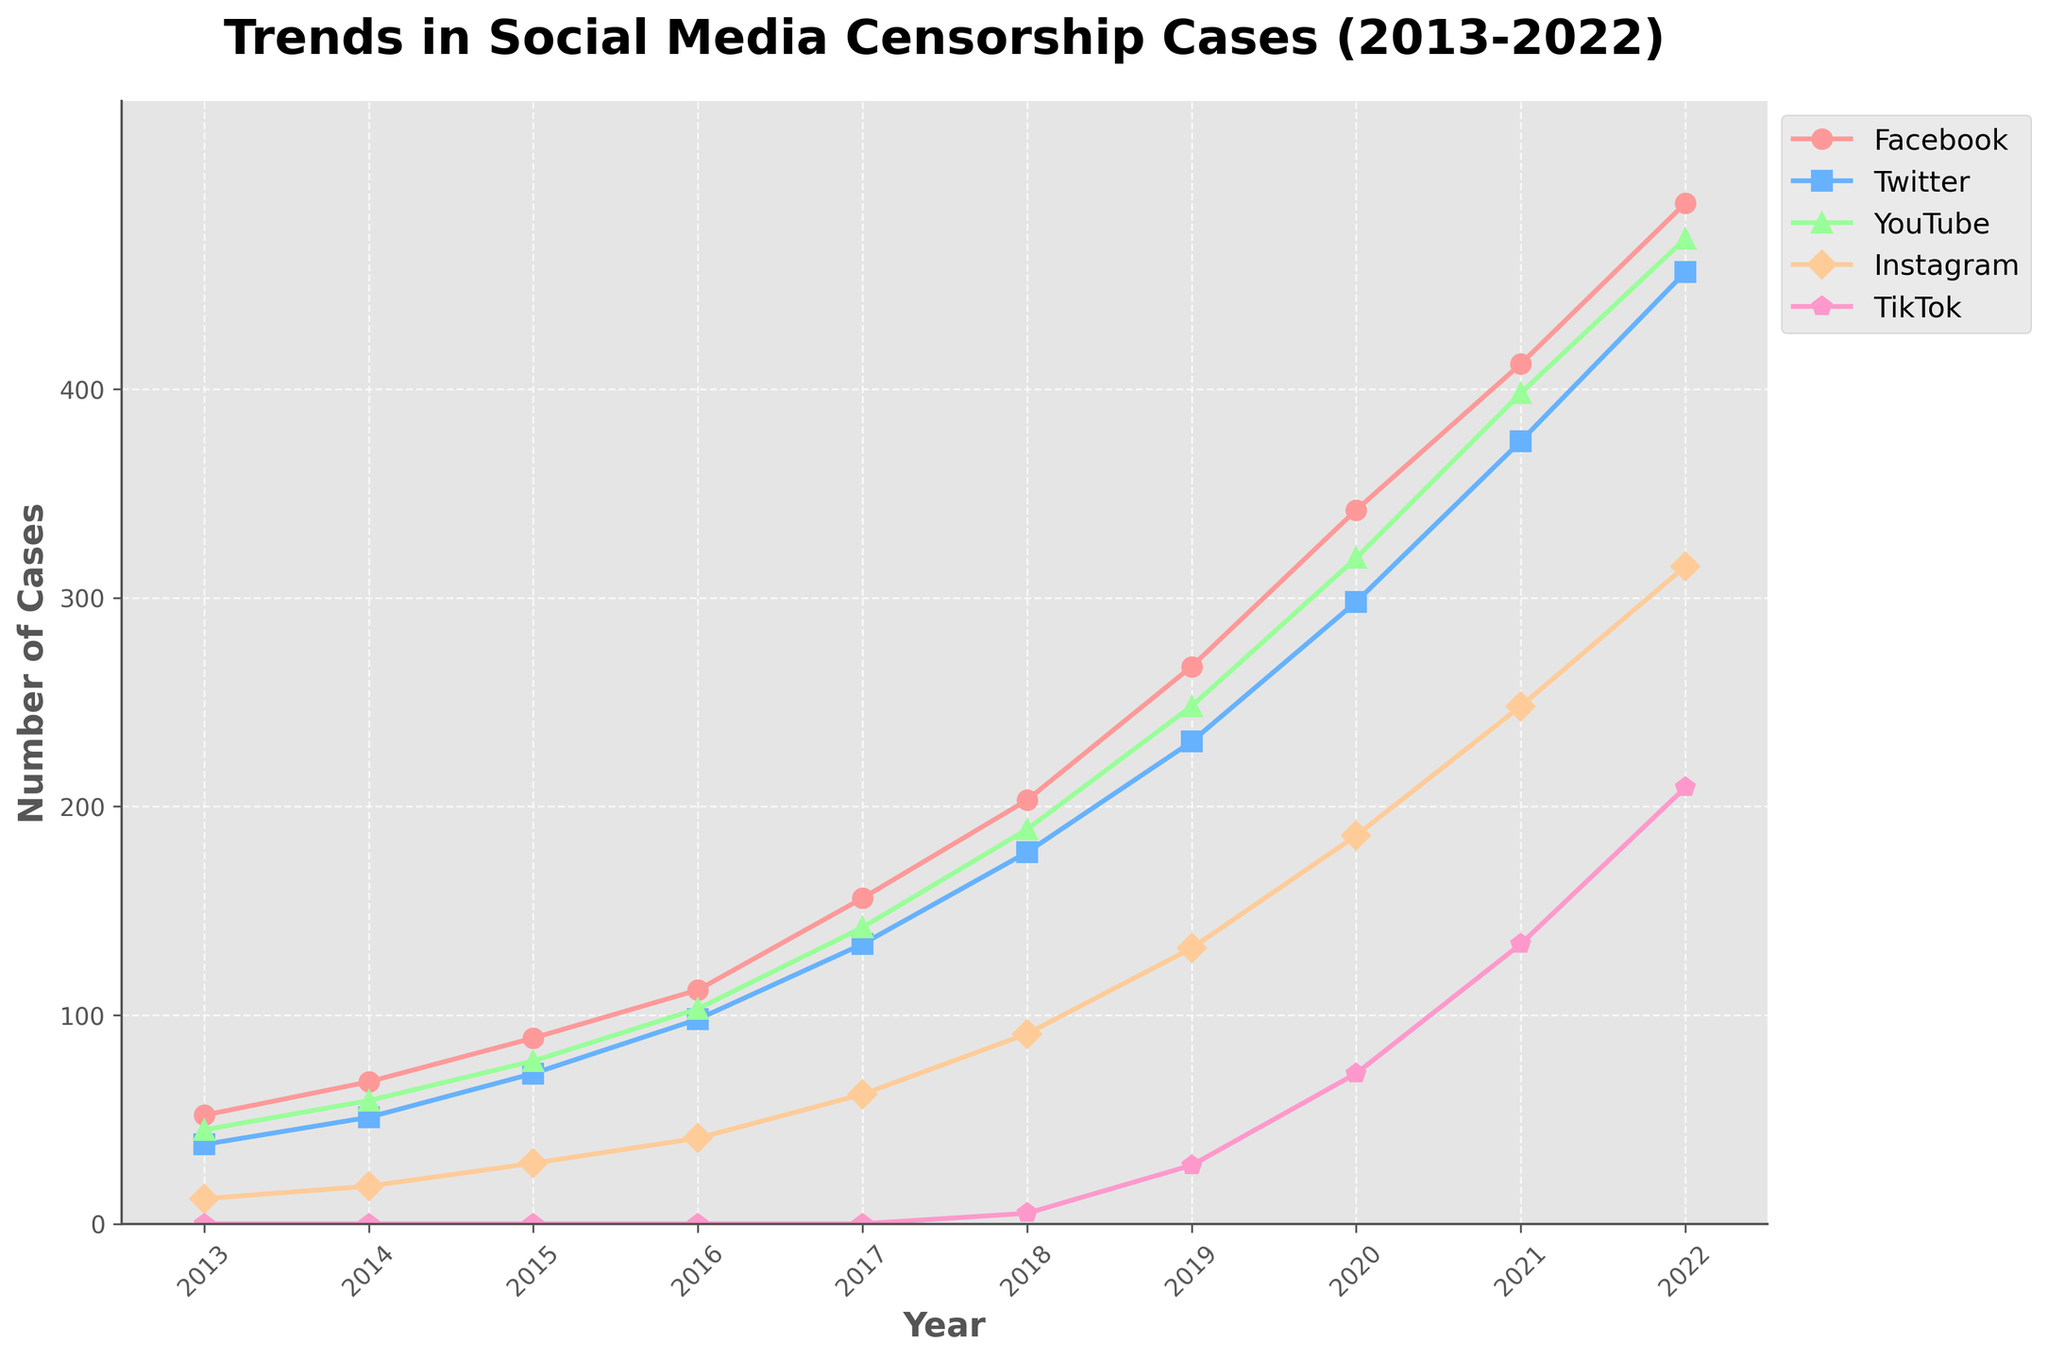What is the trend of censorship cases on Facebook over the past decade? The number of censorship cases on Facebook shows a consistent, sharp increase from 52 in 2013 to 489 in 2022.
Answer: Significant upward trend Which platform had the highest number of censorship cases in 2022? By observing the graph for the year 2022, Facebook had the highest number of cases with 489 instances.
Answer: Facebook How did the number of censorship cases on TikTok change from 2018 to 2022? In 2018, TikTok had 5 censorship cases, which increased rapidly to 209 cases by 2022.
Answer: Increased Compare the censorship trends of Facebook and Twitter between 2016 and 2020. Which platform had a sharper increase? From 2016 to 2020, Facebook cases increased from 112 to 342 (a difference of 230), while Twitter cases increased from 98 to 298 (a difference of 200). Facebook had a sharper increase.
Answer: Facebook Which year saw the highest increase in censorship cases on YouTube? The sharpest increase can be observed between 2018 and 2019, where the number of cases rose from 189 to 248. This is an increase of 59 cases.
Answer: 2019 In 2015, compare the number of censorship cases on Facebook and Instagram. How many more cases were reported on Facebook? In 2015, Facebook had 89 cases whereas Instagram had 29 cases. Therefore, Facebook had 60 more cases than Instagram.
Answer: 60 What is the trend for Instagram censorship cases from 2013 to 2022? Instagram censorship cases have steadily increased each year from 12 in 2013 to 315 in 2022.
Answer: Steady upward trend Calculate the average yearly increase in censorship cases for Twitter from 2019 to 2022. The increase in Twitter cases from 2019 (231) to 2022 (456) is 225 cases over 3 years. The average yearly increase is 225/3 = 75 cases per year.
Answer: 75 Are censorship cases on YouTube generally higher or lower than Instagram? By comparing the lines visually in the graph, YouTube generally has higher censorship cases than Instagram throughout the decade.
Answer: Higher What is the total number of censorship cases reported across all platforms in 2020? Sum of the cases in 2020 for Facebook (342), Twitter (298), YouTube (319), Instagram (186), TikTok (72) is 342 + 298 + 319 + 186 + 72 = 1217.
Answer: 1217 